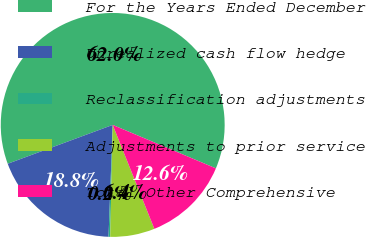Convert chart to OTSL. <chart><loc_0><loc_0><loc_500><loc_500><pie_chart><fcel>For the Years Ended December<fcel>Unrealized cash flow hedge<fcel>Reclassification adjustments<fcel>Adjustments to prior service<fcel>Total Other Comprehensive<nl><fcel>61.99%<fcel>18.77%<fcel>0.24%<fcel>6.42%<fcel>12.59%<nl></chart> 